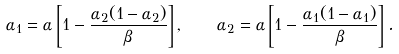Convert formula to latex. <formula><loc_0><loc_0><loc_500><loc_500>\alpha _ { 1 } = \alpha \left [ 1 - \frac { \alpha _ { 2 } ( 1 - \alpha _ { 2 } ) } { \beta } \right ] , \quad \alpha _ { 2 } = \alpha \left [ 1 - \frac { \alpha _ { 1 } ( 1 - \alpha _ { 1 } ) } { \beta } \right ] .</formula> 